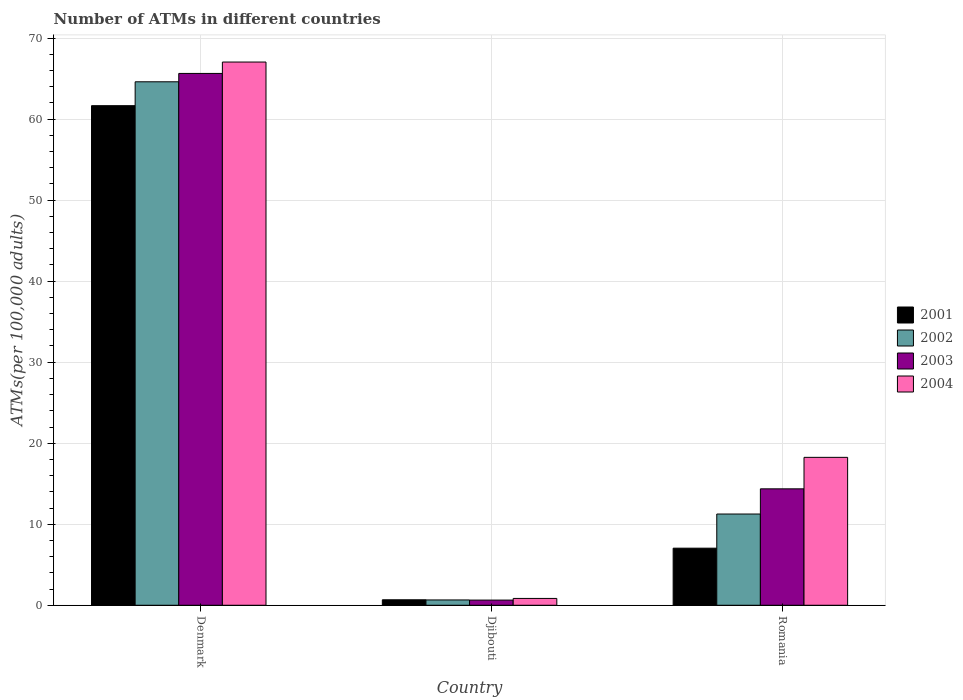How many different coloured bars are there?
Ensure brevity in your answer.  4. What is the label of the 1st group of bars from the left?
Your answer should be very brief. Denmark. What is the number of ATMs in 2002 in Djibouti?
Provide a short and direct response. 0.66. Across all countries, what is the maximum number of ATMs in 2003?
Give a very brief answer. 65.64. Across all countries, what is the minimum number of ATMs in 2002?
Offer a terse response. 0.66. In which country was the number of ATMs in 2002 minimum?
Ensure brevity in your answer.  Djibouti. What is the total number of ATMs in 2002 in the graph?
Give a very brief answer. 76.52. What is the difference between the number of ATMs in 2002 in Djibouti and that in Romania?
Keep it short and to the point. -10.6. What is the difference between the number of ATMs in 2003 in Denmark and the number of ATMs in 2004 in Djibouti?
Offer a terse response. 64.79. What is the average number of ATMs in 2001 per country?
Keep it short and to the point. 23.13. What is the difference between the number of ATMs of/in 2002 and number of ATMs of/in 2004 in Romania?
Your answer should be very brief. -7. What is the ratio of the number of ATMs in 2001 in Djibouti to that in Romania?
Your answer should be very brief. 0.1. Is the number of ATMs in 2003 in Djibouti less than that in Romania?
Your response must be concise. Yes. Is the difference between the number of ATMs in 2002 in Djibouti and Romania greater than the difference between the number of ATMs in 2004 in Djibouti and Romania?
Give a very brief answer. Yes. What is the difference between the highest and the second highest number of ATMs in 2002?
Provide a succinct answer. 63.95. What is the difference between the highest and the lowest number of ATMs in 2001?
Give a very brief answer. 60.98. In how many countries, is the number of ATMs in 2001 greater than the average number of ATMs in 2001 taken over all countries?
Provide a succinct answer. 1. Is it the case that in every country, the sum of the number of ATMs in 2002 and number of ATMs in 2003 is greater than the sum of number of ATMs in 2004 and number of ATMs in 2001?
Offer a terse response. No. What does the 4th bar from the right in Djibouti represents?
Ensure brevity in your answer.  2001. Is it the case that in every country, the sum of the number of ATMs in 2004 and number of ATMs in 2002 is greater than the number of ATMs in 2003?
Provide a succinct answer. Yes. How many bars are there?
Make the answer very short. 12. Are all the bars in the graph horizontal?
Your response must be concise. No. How many countries are there in the graph?
Your response must be concise. 3. Are the values on the major ticks of Y-axis written in scientific E-notation?
Keep it short and to the point. No. Does the graph contain grids?
Offer a very short reply. Yes. Where does the legend appear in the graph?
Ensure brevity in your answer.  Center right. How many legend labels are there?
Offer a very short reply. 4. How are the legend labels stacked?
Give a very brief answer. Vertical. What is the title of the graph?
Your answer should be compact. Number of ATMs in different countries. Does "1986" appear as one of the legend labels in the graph?
Give a very brief answer. No. What is the label or title of the X-axis?
Ensure brevity in your answer.  Country. What is the label or title of the Y-axis?
Make the answer very short. ATMs(per 100,0 adults). What is the ATMs(per 100,000 adults) in 2001 in Denmark?
Your response must be concise. 61.66. What is the ATMs(per 100,000 adults) of 2002 in Denmark?
Ensure brevity in your answer.  64.61. What is the ATMs(per 100,000 adults) in 2003 in Denmark?
Your answer should be compact. 65.64. What is the ATMs(per 100,000 adults) in 2004 in Denmark?
Your response must be concise. 67.04. What is the ATMs(per 100,000 adults) in 2001 in Djibouti?
Your answer should be compact. 0.68. What is the ATMs(per 100,000 adults) of 2002 in Djibouti?
Ensure brevity in your answer.  0.66. What is the ATMs(per 100,000 adults) in 2003 in Djibouti?
Give a very brief answer. 0.64. What is the ATMs(per 100,000 adults) in 2004 in Djibouti?
Your answer should be very brief. 0.84. What is the ATMs(per 100,000 adults) of 2001 in Romania?
Give a very brief answer. 7.04. What is the ATMs(per 100,000 adults) in 2002 in Romania?
Provide a succinct answer. 11.26. What is the ATMs(per 100,000 adults) of 2003 in Romania?
Offer a terse response. 14.37. What is the ATMs(per 100,000 adults) of 2004 in Romania?
Your answer should be very brief. 18.26. Across all countries, what is the maximum ATMs(per 100,000 adults) of 2001?
Your answer should be compact. 61.66. Across all countries, what is the maximum ATMs(per 100,000 adults) of 2002?
Your answer should be very brief. 64.61. Across all countries, what is the maximum ATMs(per 100,000 adults) of 2003?
Ensure brevity in your answer.  65.64. Across all countries, what is the maximum ATMs(per 100,000 adults) in 2004?
Give a very brief answer. 67.04. Across all countries, what is the minimum ATMs(per 100,000 adults) in 2001?
Your answer should be compact. 0.68. Across all countries, what is the minimum ATMs(per 100,000 adults) of 2002?
Offer a very short reply. 0.66. Across all countries, what is the minimum ATMs(per 100,000 adults) in 2003?
Ensure brevity in your answer.  0.64. Across all countries, what is the minimum ATMs(per 100,000 adults) in 2004?
Make the answer very short. 0.84. What is the total ATMs(per 100,000 adults) in 2001 in the graph?
Give a very brief answer. 69.38. What is the total ATMs(per 100,000 adults) of 2002 in the graph?
Provide a short and direct response. 76.52. What is the total ATMs(per 100,000 adults) of 2003 in the graph?
Offer a terse response. 80.65. What is the total ATMs(per 100,000 adults) in 2004 in the graph?
Offer a terse response. 86.14. What is the difference between the ATMs(per 100,000 adults) in 2001 in Denmark and that in Djibouti?
Keep it short and to the point. 60.98. What is the difference between the ATMs(per 100,000 adults) of 2002 in Denmark and that in Djibouti?
Provide a short and direct response. 63.95. What is the difference between the ATMs(per 100,000 adults) of 2003 in Denmark and that in Djibouti?
Offer a terse response. 65. What is the difference between the ATMs(per 100,000 adults) in 2004 in Denmark and that in Djibouti?
Provide a succinct answer. 66.2. What is the difference between the ATMs(per 100,000 adults) in 2001 in Denmark and that in Romania?
Provide a short and direct response. 54.61. What is the difference between the ATMs(per 100,000 adults) in 2002 in Denmark and that in Romania?
Your response must be concise. 53.35. What is the difference between the ATMs(per 100,000 adults) in 2003 in Denmark and that in Romania?
Ensure brevity in your answer.  51.27. What is the difference between the ATMs(per 100,000 adults) of 2004 in Denmark and that in Romania?
Ensure brevity in your answer.  48.79. What is the difference between the ATMs(per 100,000 adults) of 2001 in Djibouti and that in Romania?
Provide a short and direct response. -6.37. What is the difference between the ATMs(per 100,000 adults) in 2002 in Djibouti and that in Romania?
Ensure brevity in your answer.  -10.6. What is the difference between the ATMs(per 100,000 adults) in 2003 in Djibouti and that in Romania?
Keep it short and to the point. -13.73. What is the difference between the ATMs(per 100,000 adults) of 2004 in Djibouti and that in Romania?
Provide a succinct answer. -17.41. What is the difference between the ATMs(per 100,000 adults) in 2001 in Denmark and the ATMs(per 100,000 adults) in 2002 in Djibouti?
Give a very brief answer. 61. What is the difference between the ATMs(per 100,000 adults) in 2001 in Denmark and the ATMs(per 100,000 adults) in 2003 in Djibouti?
Your response must be concise. 61.02. What is the difference between the ATMs(per 100,000 adults) of 2001 in Denmark and the ATMs(per 100,000 adults) of 2004 in Djibouti?
Provide a short and direct response. 60.81. What is the difference between the ATMs(per 100,000 adults) of 2002 in Denmark and the ATMs(per 100,000 adults) of 2003 in Djibouti?
Provide a succinct answer. 63.97. What is the difference between the ATMs(per 100,000 adults) of 2002 in Denmark and the ATMs(per 100,000 adults) of 2004 in Djibouti?
Make the answer very short. 63.76. What is the difference between the ATMs(per 100,000 adults) in 2003 in Denmark and the ATMs(per 100,000 adults) in 2004 in Djibouti?
Keep it short and to the point. 64.79. What is the difference between the ATMs(per 100,000 adults) in 2001 in Denmark and the ATMs(per 100,000 adults) in 2002 in Romania?
Provide a short and direct response. 50.4. What is the difference between the ATMs(per 100,000 adults) in 2001 in Denmark and the ATMs(per 100,000 adults) in 2003 in Romania?
Keep it short and to the point. 47.29. What is the difference between the ATMs(per 100,000 adults) of 2001 in Denmark and the ATMs(per 100,000 adults) of 2004 in Romania?
Keep it short and to the point. 43.4. What is the difference between the ATMs(per 100,000 adults) in 2002 in Denmark and the ATMs(per 100,000 adults) in 2003 in Romania?
Offer a very short reply. 50.24. What is the difference between the ATMs(per 100,000 adults) of 2002 in Denmark and the ATMs(per 100,000 adults) of 2004 in Romania?
Offer a terse response. 46.35. What is the difference between the ATMs(per 100,000 adults) in 2003 in Denmark and the ATMs(per 100,000 adults) in 2004 in Romania?
Offer a terse response. 47.38. What is the difference between the ATMs(per 100,000 adults) in 2001 in Djibouti and the ATMs(per 100,000 adults) in 2002 in Romania?
Keep it short and to the point. -10.58. What is the difference between the ATMs(per 100,000 adults) in 2001 in Djibouti and the ATMs(per 100,000 adults) in 2003 in Romania?
Make the answer very short. -13.69. What is the difference between the ATMs(per 100,000 adults) of 2001 in Djibouti and the ATMs(per 100,000 adults) of 2004 in Romania?
Provide a short and direct response. -17.58. What is the difference between the ATMs(per 100,000 adults) of 2002 in Djibouti and the ATMs(per 100,000 adults) of 2003 in Romania?
Give a very brief answer. -13.71. What is the difference between the ATMs(per 100,000 adults) in 2002 in Djibouti and the ATMs(per 100,000 adults) in 2004 in Romania?
Give a very brief answer. -17.6. What is the difference between the ATMs(per 100,000 adults) of 2003 in Djibouti and the ATMs(per 100,000 adults) of 2004 in Romania?
Keep it short and to the point. -17.62. What is the average ATMs(per 100,000 adults) in 2001 per country?
Give a very brief answer. 23.13. What is the average ATMs(per 100,000 adults) of 2002 per country?
Ensure brevity in your answer.  25.51. What is the average ATMs(per 100,000 adults) of 2003 per country?
Provide a short and direct response. 26.88. What is the average ATMs(per 100,000 adults) in 2004 per country?
Offer a terse response. 28.71. What is the difference between the ATMs(per 100,000 adults) of 2001 and ATMs(per 100,000 adults) of 2002 in Denmark?
Your answer should be very brief. -2.95. What is the difference between the ATMs(per 100,000 adults) in 2001 and ATMs(per 100,000 adults) in 2003 in Denmark?
Your answer should be very brief. -3.98. What is the difference between the ATMs(per 100,000 adults) in 2001 and ATMs(per 100,000 adults) in 2004 in Denmark?
Your answer should be very brief. -5.39. What is the difference between the ATMs(per 100,000 adults) in 2002 and ATMs(per 100,000 adults) in 2003 in Denmark?
Offer a very short reply. -1.03. What is the difference between the ATMs(per 100,000 adults) in 2002 and ATMs(per 100,000 adults) in 2004 in Denmark?
Provide a short and direct response. -2.44. What is the difference between the ATMs(per 100,000 adults) of 2003 and ATMs(per 100,000 adults) of 2004 in Denmark?
Offer a very short reply. -1.41. What is the difference between the ATMs(per 100,000 adults) of 2001 and ATMs(per 100,000 adults) of 2002 in Djibouti?
Offer a terse response. 0.02. What is the difference between the ATMs(per 100,000 adults) in 2001 and ATMs(per 100,000 adults) in 2003 in Djibouti?
Give a very brief answer. 0.04. What is the difference between the ATMs(per 100,000 adults) of 2001 and ATMs(per 100,000 adults) of 2004 in Djibouti?
Make the answer very short. -0.17. What is the difference between the ATMs(per 100,000 adults) of 2002 and ATMs(per 100,000 adults) of 2003 in Djibouti?
Provide a short and direct response. 0.02. What is the difference between the ATMs(per 100,000 adults) of 2002 and ATMs(per 100,000 adults) of 2004 in Djibouti?
Your response must be concise. -0.19. What is the difference between the ATMs(per 100,000 adults) in 2003 and ATMs(per 100,000 adults) in 2004 in Djibouti?
Make the answer very short. -0.21. What is the difference between the ATMs(per 100,000 adults) of 2001 and ATMs(per 100,000 adults) of 2002 in Romania?
Ensure brevity in your answer.  -4.21. What is the difference between the ATMs(per 100,000 adults) in 2001 and ATMs(per 100,000 adults) in 2003 in Romania?
Your answer should be compact. -7.32. What is the difference between the ATMs(per 100,000 adults) of 2001 and ATMs(per 100,000 adults) of 2004 in Romania?
Give a very brief answer. -11.21. What is the difference between the ATMs(per 100,000 adults) of 2002 and ATMs(per 100,000 adults) of 2003 in Romania?
Your answer should be compact. -3.11. What is the difference between the ATMs(per 100,000 adults) of 2002 and ATMs(per 100,000 adults) of 2004 in Romania?
Your answer should be compact. -7. What is the difference between the ATMs(per 100,000 adults) of 2003 and ATMs(per 100,000 adults) of 2004 in Romania?
Give a very brief answer. -3.89. What is the ratio of the ATMs(per 100,000 adults) of 2001 in Denmark to that in Djibouti?
Your answer should be compact. 91.18. What is the ratio of the ATMs(per 100,000 adults) of 2002 in Denmark to that in Djibouti?
Your answer should be compact. 98.45. What is the ratio of the ATMs(per 100,000 adults) in 2003 in Denmark to that in Djibouti?
Your answer should be compact. 102.88. What is the ratio of the ATMs(per 100,000 adults) in 2004 in Denmark to that in Djibouti?
Provide a short and direct response. 79.46. What is the ratio of the ATMs(per 100,000 adults) in 2001 in Denmark to that in Romania?
Give a very brief answer. 8.75. What is the ratio of the ATMs(per 100,000 adults) in 2002 in Denmark to that in Romania?
Your answer should be very brief. 5.74. What is the ratio of the ATMs(per 100,000 adults) in 2003 in Denmark to that in Romania?
Give a very brief answer. 4.57. What is the ratio of the ATMs(per 100,000 adults) in 2004 in Denmark to that in Romania?
Keep it short and to the point. 3.67. What is the ratio of the ATMs(per 100,000 adults) of 2001 in Djibouti to that in Romania?
Keep it short and to the point. 0.1. What is the ratio of the ATMs(per 100,000 adults) of 2002 in Djibouti to that in Romania?
Your response must be concise. 0.06. What is the ratio of the ATMs(per 100,000 adults) in 2003 in Djibouti to that in Romania?
Keep it short and to the point. 0.04. What is the ratio of the ATMs(per 100,000 adults) in 2004 in Djibouti to that in Romania?
Provide a short and direct response. 0.05. What is the difference between the highest and the second highest ATMs(per 100,000 adults) of 2001?
Ensure brevity in your answer.  54.61. What is the difference between the highest and the second highest ATMs(per 100,000 adults) in 2002?
Give a very brief answer. 53.35. What is the difference between the highest and the second highest ATMs(per 100,000 adults) of 2003?
Provide a succinct answer. 51.27. What is the difference between the highest and the second highest ATMs(per 100,000 adults) of 2004?
Your answer should be very brief. 48.79. What is the difference between the highest and the lowest ATMs(per 100,000 adults) of 2001?
Offer a very short reply. 60.98. What is the difference between the highest and the lowest ATMs(per 100,000 adults) of 2002?
Give a very brief answer. 63.95. What is the difference between the highest and the lowest ATMs(per 100,000 adults) of 2003?
Ensure brevity in your answer.  65. What is the difference between the highest and the lowest ATMs(per 100,000 adults) of 2004?
Keep it short and to the point. 66.2. 